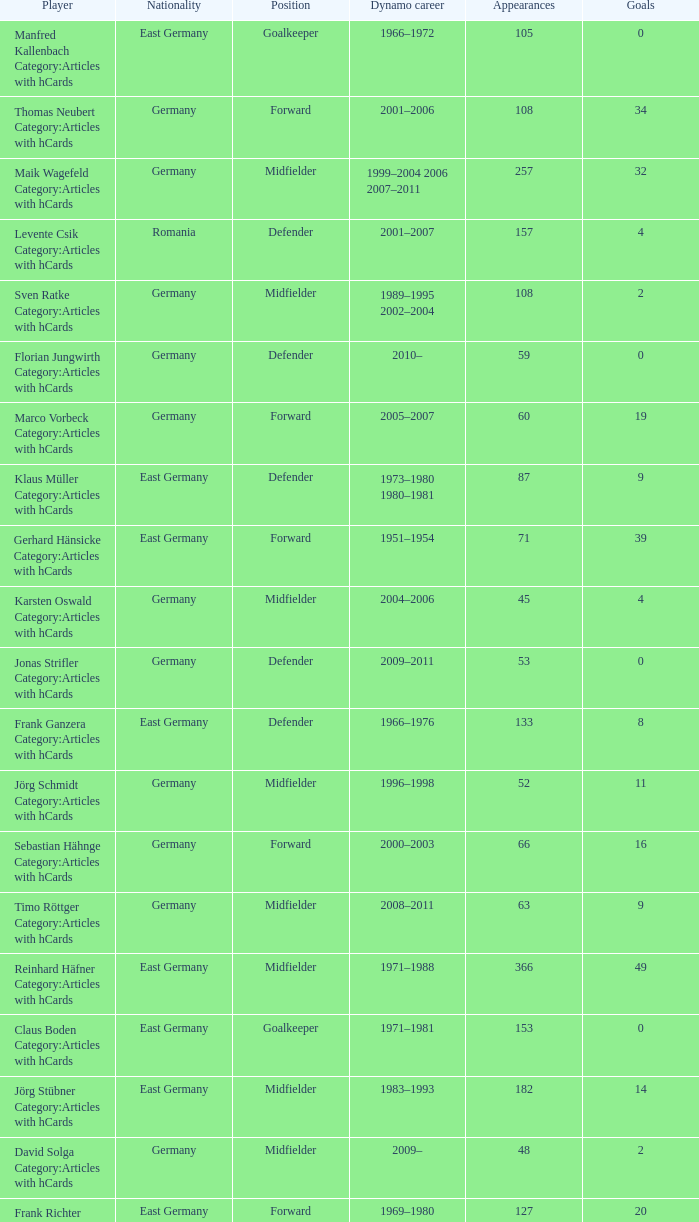What was the position of the player with 57 goals? Forward. 